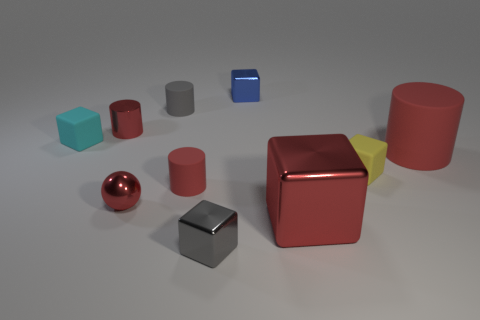Subtract all cyan rubber cubes. How many cubes are left? 4 Subtract 4 cubes. How many cubes are left? 1 Subtract all gray cubes. How many cubes are left? 4 Subtract all cylinders. How many objects are left? 6 Subtract 0 blue spheres. How many objects are left? 10 Subtract all brown spheres. Subtract all purple cubes. How many spheres are left? 1 Subtract all purple spheres. How many gray blocks are left? 1 Subtract all tiny blue rubber objects. Subtract all tiny blue metallic blocks. How many objects are left? 9 Add 7 gray cylinders. How many gray cylinders are left? 8 Add 6 small gray cylinders. How many small gray cylinders exist? 7 